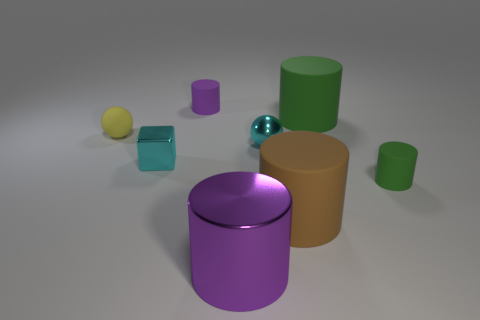Subtract all small rubber cylinders. How many cylinders are left? 3 Subtract 1 spheres. How many spheres are left? 1 Add 1 gray shiny cylinders. How many objects exist? 9 Subtract all cubes. How many objects are left? 7 Subtract all brown cylinders. How many cylinders are left? 4 Add 5 tiny rubber balls. How many tiny rubber balls exist? 6 Subtract 1 brown cylinders. How many objects are left? 7 Subtract all purple cylinders. Subtract all red blocks. How many cylinders are left? 3 Subtract all brown cubes. How many cyan balls are left? 1 Subtract all big cyan cylinders. Subtract all big cylinders. How many objects are left? 5 